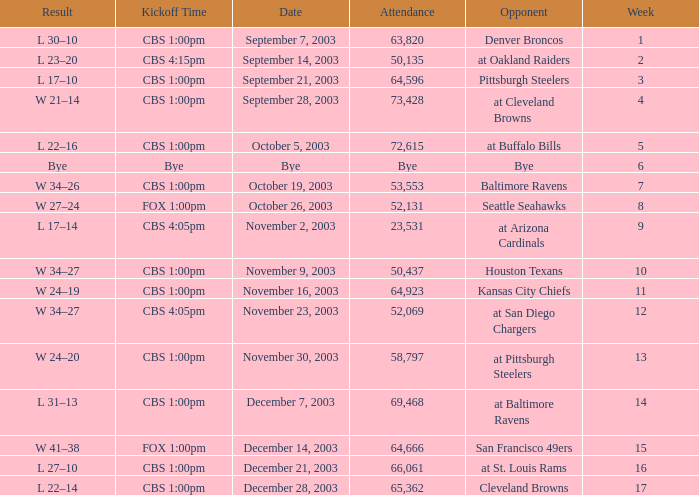What was the kickoff time on week 1? CBS 1:00pm. 